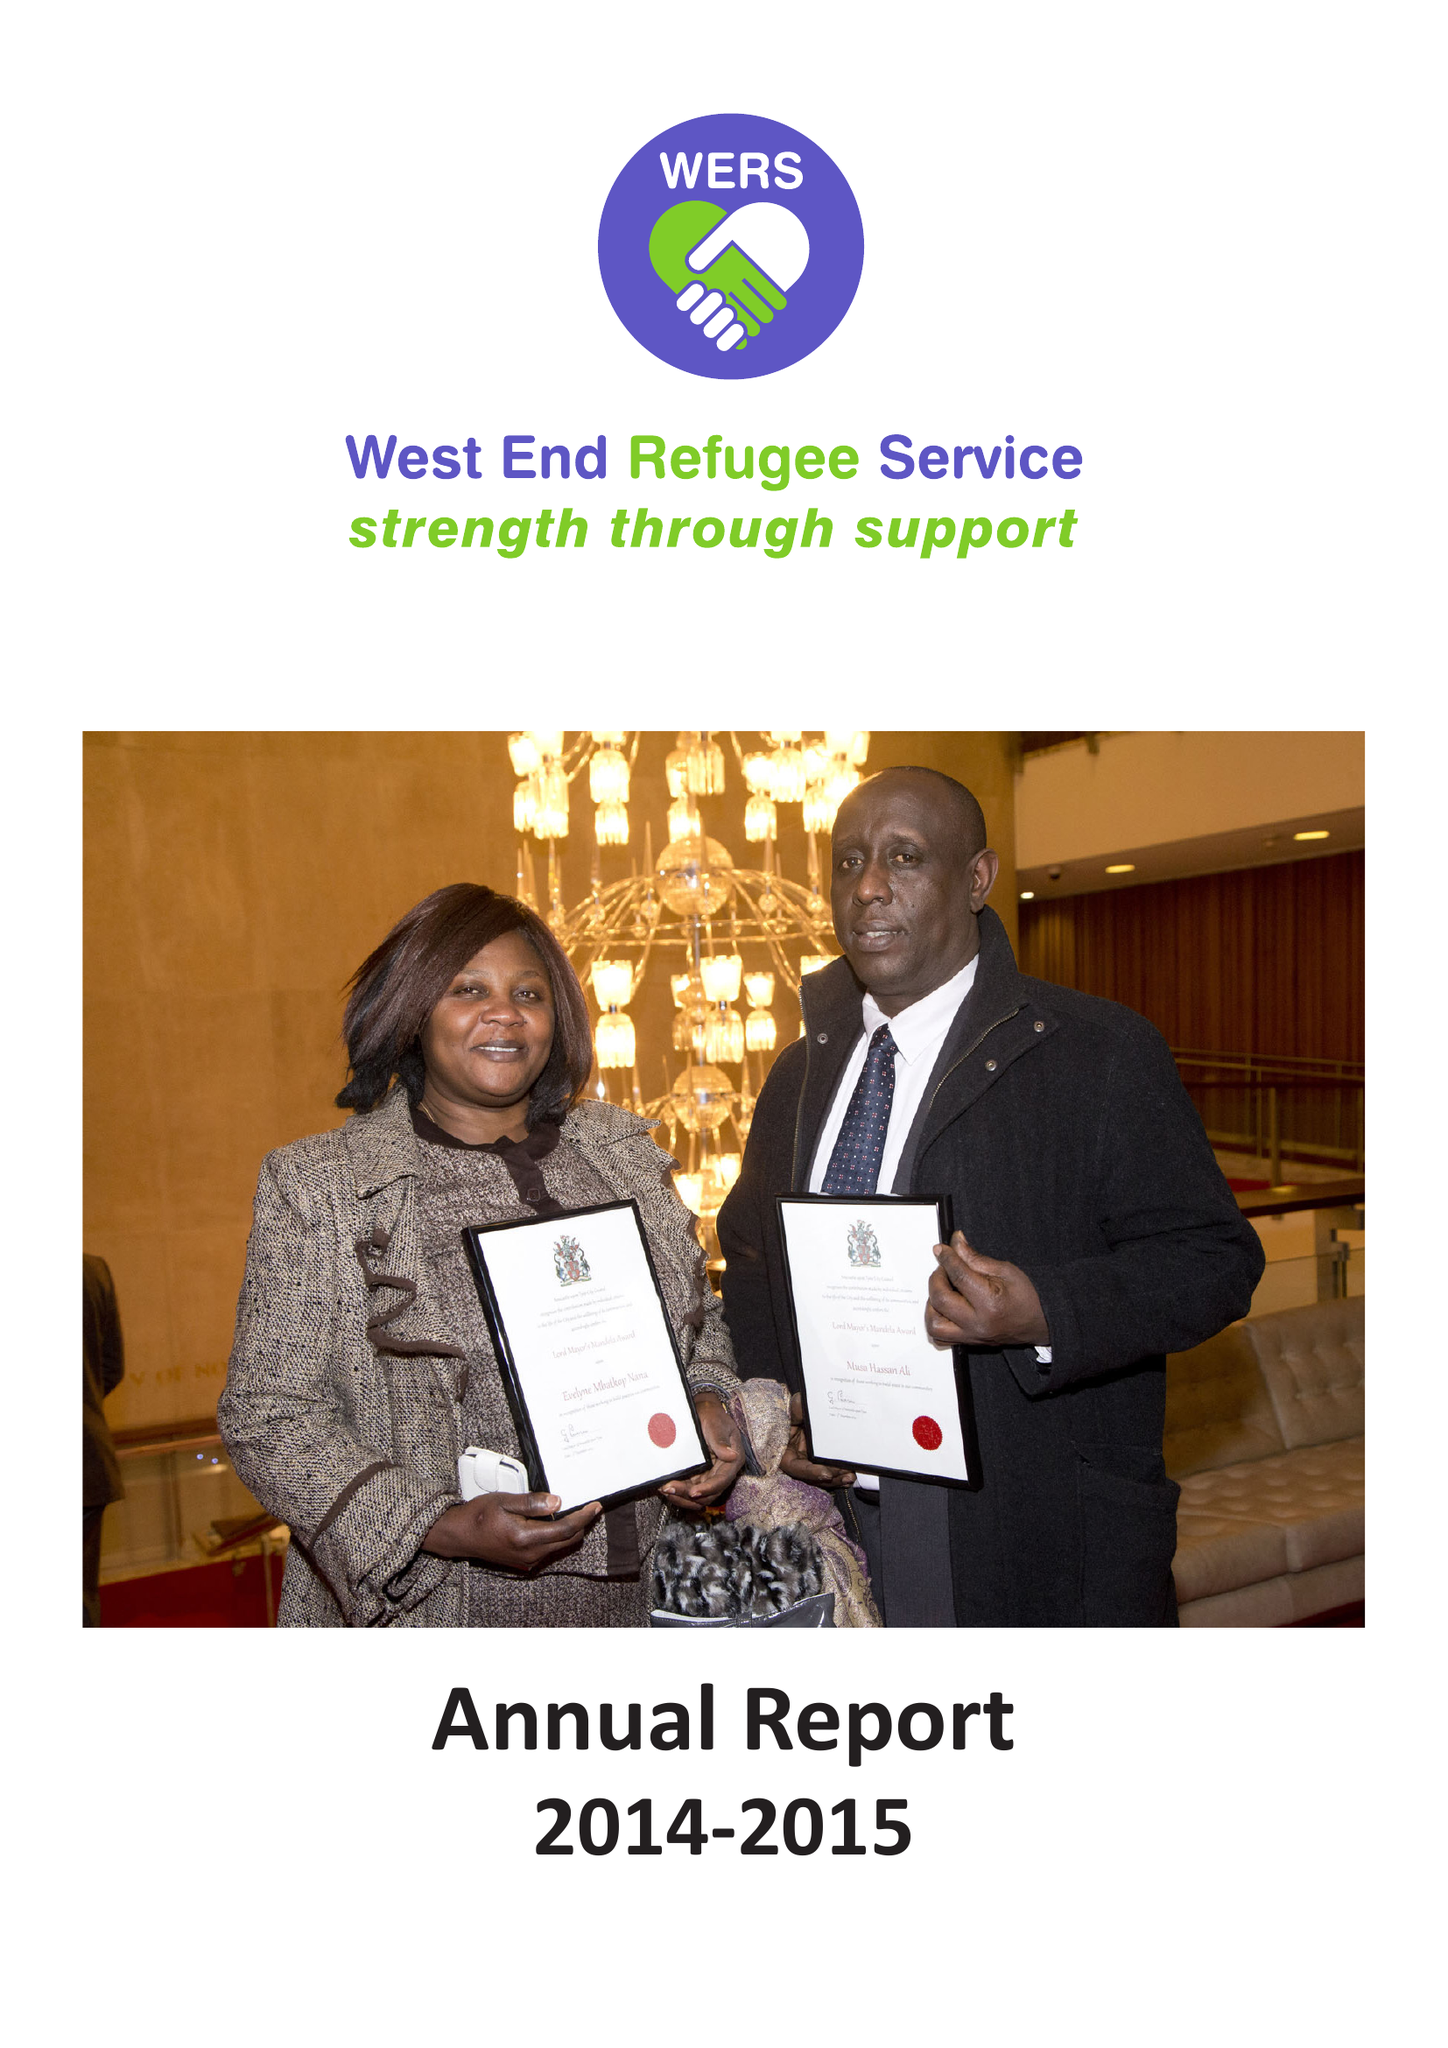What is the value for the charity_number?
Answer the question using a single word or phrase. 1077601 